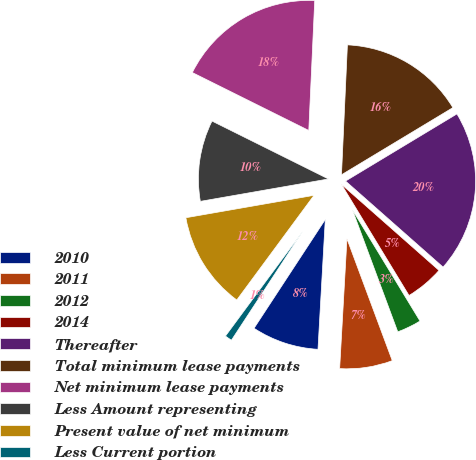<chart> <loc_0><loc_0><loc_500><loc_500><pie_chart><fcel>2010<fcel>2011<fcel>2012<fcel>2014<fcel>Thereafter<fcel>Total minimum lease payments<fcel>Net minimum lease payments<fcel>Less Amount representing<fcel>Present value of net minimum<fcel>Less Current portion<nl><fcel>8.33%<fcel>6.56%<fcel>3.03%<fcel>4.8%<fcel>20.14%<fcel>15.64%<fcel>18.38%<fcel>10.1%<fcel>12.13%<fcel>0.89%<nl></chart> 